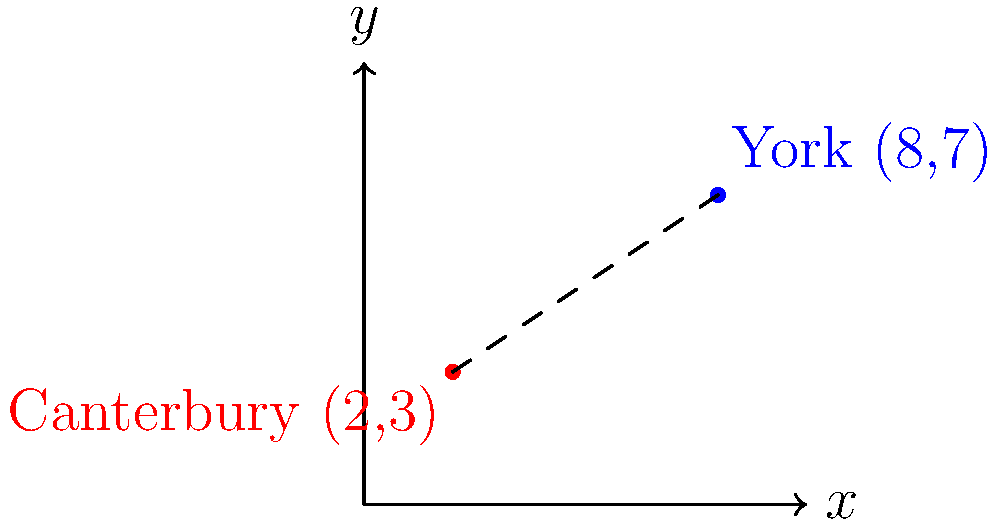Two of England's most historically significant cathedrals, Canterbury Cathedral and York Minster, are represented on a coordinate plane. Canterbury Cathedral is located at (2,3) and York Minster at (8,7). Using the distance formula, calculate the distance between these two cathedrals on this coordinate system. Round your answer to two decimal places. To solve this problem, we'll use the distance formula derived from the Pythagorean theorem:

$$d = \sqrt{(x_2-x_1)^2 + (y_2-y_1)^2}$$

Where:
$(x_1,y_1)$ represents the coordinates of Canterbury Cathedral (2,3)
$(x_2,y_2)$ represents the coordinates of York Minster (8,7)

Let's substitute these values into the formula:

$$d = \sqrt{(8-2)^2 + (7-3)^2}$$

Now, let's solve step-by-step:

1) Simplify inside the parentheses:
   $$d = \sqrt{6^2 + 4^2}$$

2) Calculate the squares:
   $$d = \sqrt{36 + 16}$$

3) Add under the square root:
   $$d = \sqrt{52}$$

4) Simplify the square root:
   $$d = 2\sqrt{13}$$

5) Use a calculator to approximate and round to two decimal places:
   $$d \approx 7.21$$

Therefore, the distance between Canterbury Cathedral and York Minster on this coordinate system is approximately 7.21 units.
Answer: 7.21 units 